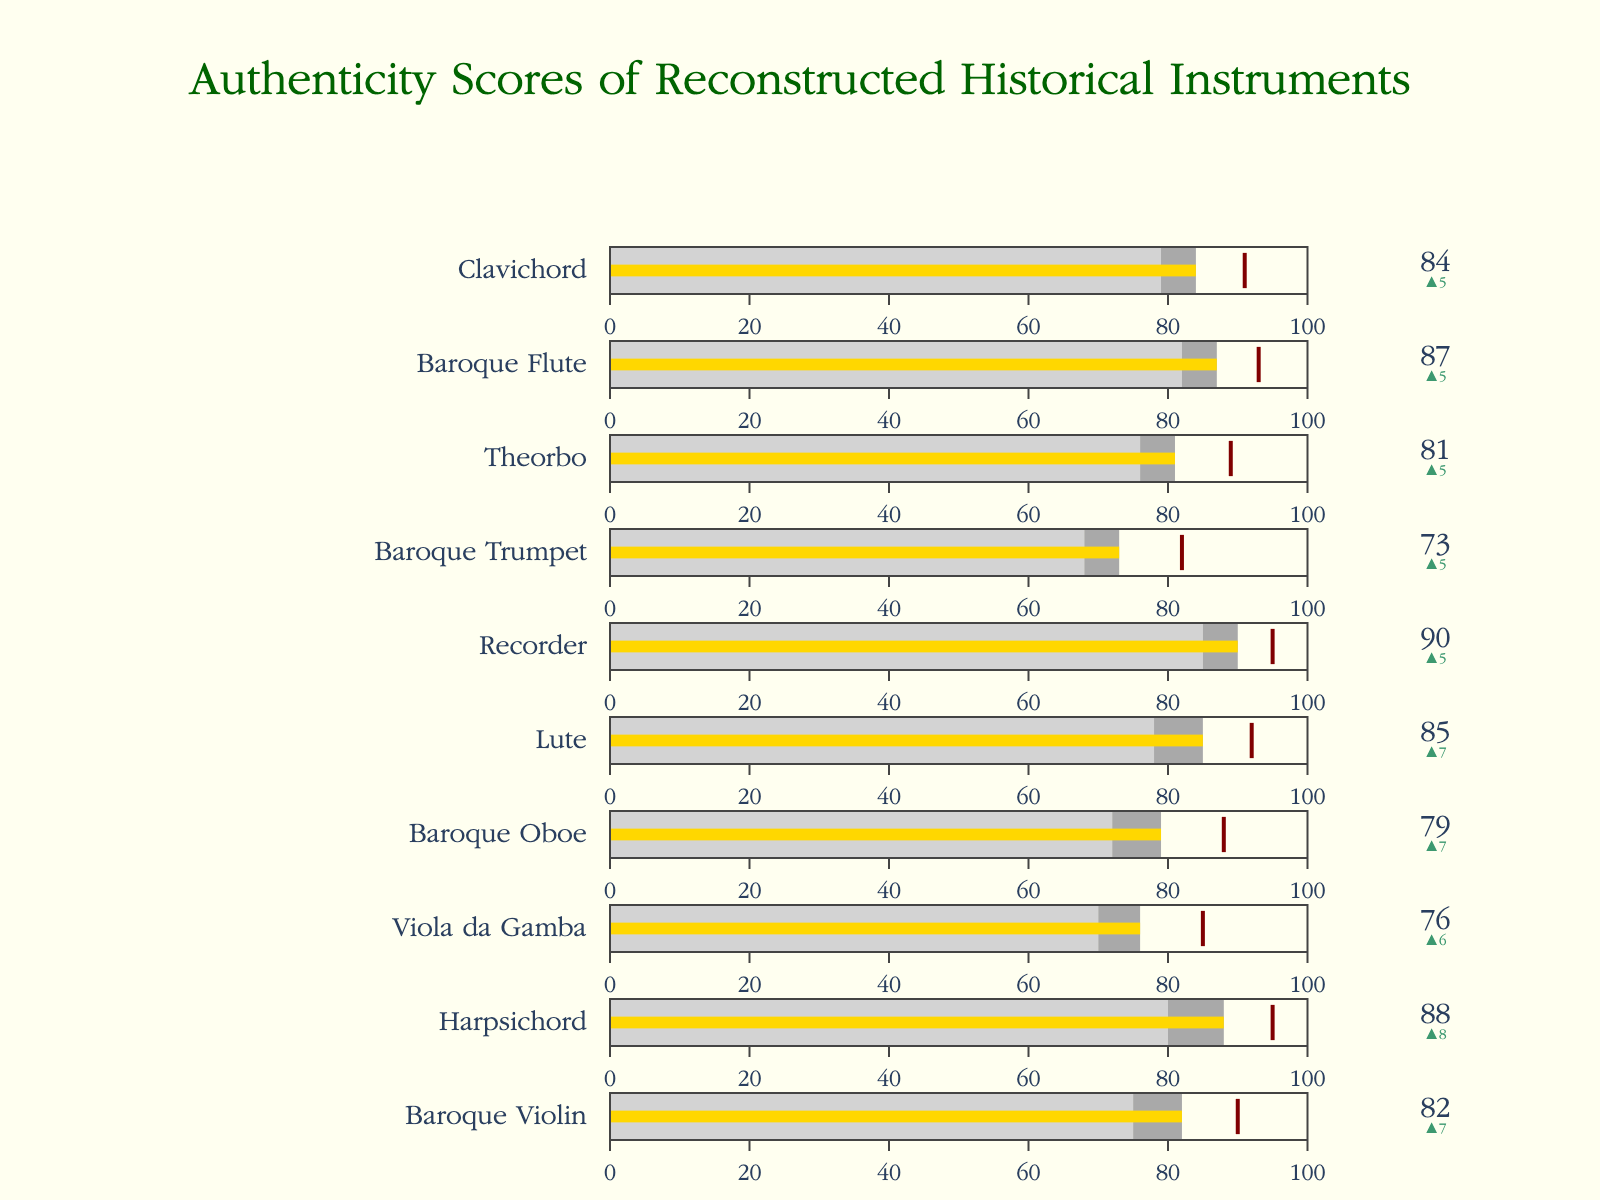How many instruments are compared in the bullet chart? Count the number of individual gauges, which corresponds to the number of instruments.
Answer: 10 Which instrument has the highest actual score? Identify the instrument with the highest value on the bullet chart.
Answer: Recorder What is the range of the comparative scores for the Viola da Gamba and the Baroque Trumpet? Subtract the comparative score of the Baroque Trumpet (68) from the comparative score of the Viola da Gamba (70).
Answer: 2 Which two instruments have the smallest delta value between the actual score and the comparative score? Calculate the difference between the actual and comparative scores for each instrument and find the smallest.
Answer: Recorder and Harpsichord Which instrument's actual score is furthest from its target score? Subtract each instrument's actual score from its target score and identify the largest difference.
Answer: Baroque Trumpet What is the average actual score of all the instruments? Sum all actual scores and divide by the number of instruments. (82 + 88 + 76 + 79 + 85 + 90 + 73 + 81 + 87 + 84) / 10 = 82.5
Answer: 82.5 Which instrument has the closest actual score to its target score? Subtract each actual score from its target score and identify the smallest absolute difference.
Answer: Clavichord How many instruments exceed their comparative scores by at least 5 points? Determine the difference between the actual and comparative scores for each instrument, then count how many are greater than or equal to 5.
Answer: 6 Which instrument shows the largest improvement from the comparative score to the actual score? Calculate the difference (delta) for each instrument and find the largest improvement.
Answer: Baroque Trumpet What is the total delta value across all instruments? Sum all the delta values, which are the differences between actual and comparative scores. (82-75) + (88-80) + (76-70) + (79-72) + (85-78) + (90-85) + (73-68) + (81-76) + (87-82) + (84-79) = 29
Answer: 29 